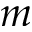<formula> <loc_0><loc_0><loc_500><loc_500>m</formula> 